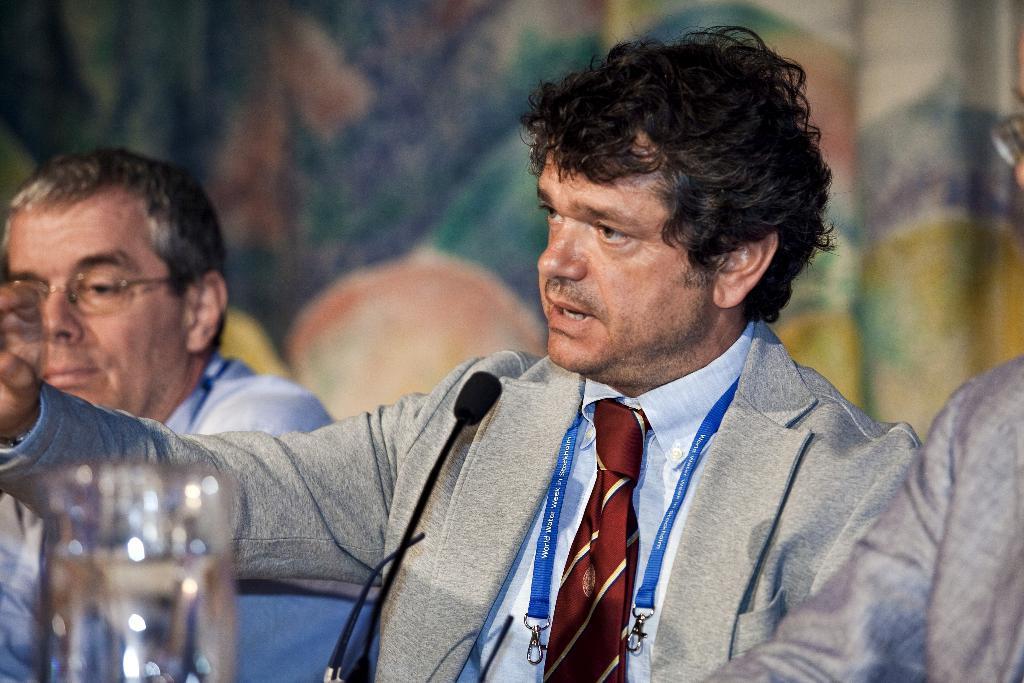Could you give a brief overview of what you see in this image? In this picture there is a man who is wearing blazer, shirt and tie. He is sitting near to the table. On the table we can see mic and water glass. On the left there is another man who is wearing spectacle and shirt. In the back we can see cloth. On the right there is a man who is wearing spectacle and shirt. 